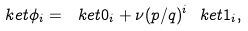Convert formula to latex. <formula><loc_0><loc_0><loc_500><loc_500>\ k e t { \phi } _ { i } = \ k e t { 0 } _ { i } + \nu ( p / q ) ^ { i } \ k e t { 1 } _ { i } ,</formula> 